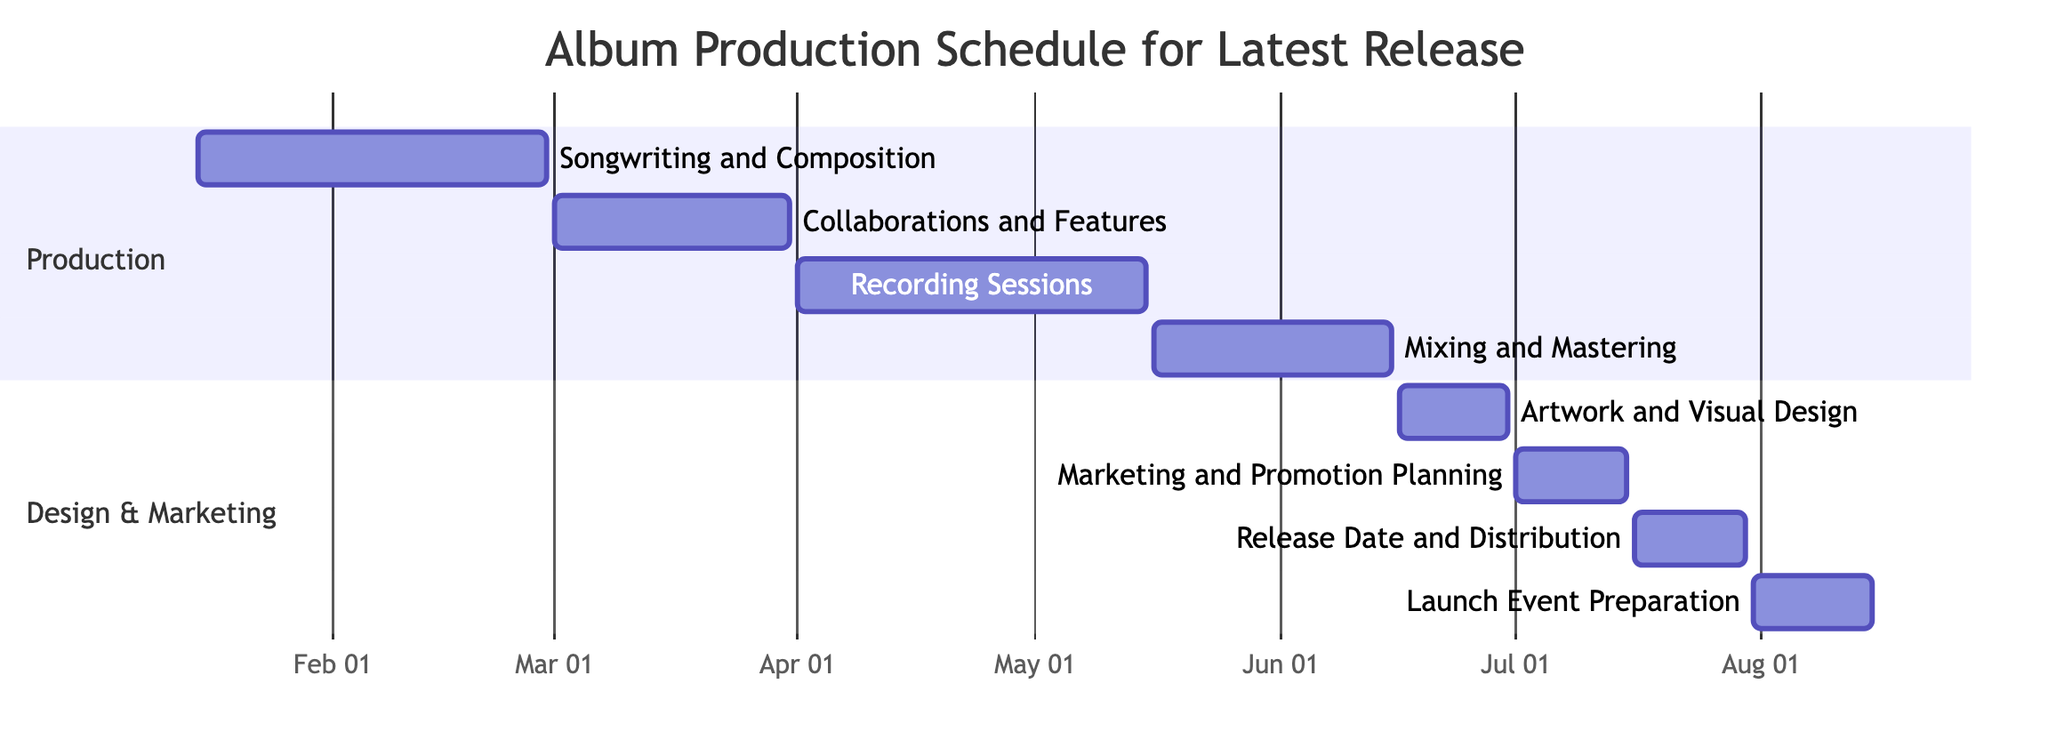What is the duration of the "Collaborations and Features" task? The "Collaborations and Features" task starts on March 1, 2023, and ends on March 31, 2023. Counting from the start to the end date inclusive, it has a total of 31 days.
Answer: 31 days During which months does the "Mixing and Mastering" phase occur? The "Mixing and Mastering" task runs from May 16, 2023, to June 15, 2023. Therefore, it spans across May and June.
Answer: May and June How many tasks are scheduled in the "Design & Marketing" section? The "Design & Marketing" section contains four tasks: Artwork and Visual Design, Marketing and Promotion Planning, Release Date and Distribution, and Launch Event Preparation. Counting these gives a total of 4 tasks.
Answer: 4 tasks Which task immediately follows "Recording Sessions"? The task following "Recording Sessions," which ends on May 15, 2023, is "Mixing and Mastering," which starts on May 16, 2023. The close proximity of the end date of one task and the start date of the next indicates direct succession.
Answer: Mixing and Mastering What is the total timeframe from "Songwriting and Composition" to "Launch Event Preparation"? "Songwriting and Composition" starts on January 15, 2023, and "Launch Event Preparation" ends on August 15, 2023. This spans from the start of the first task to the end of the last task, which is a total of 212 days.
Answer: 212 days 